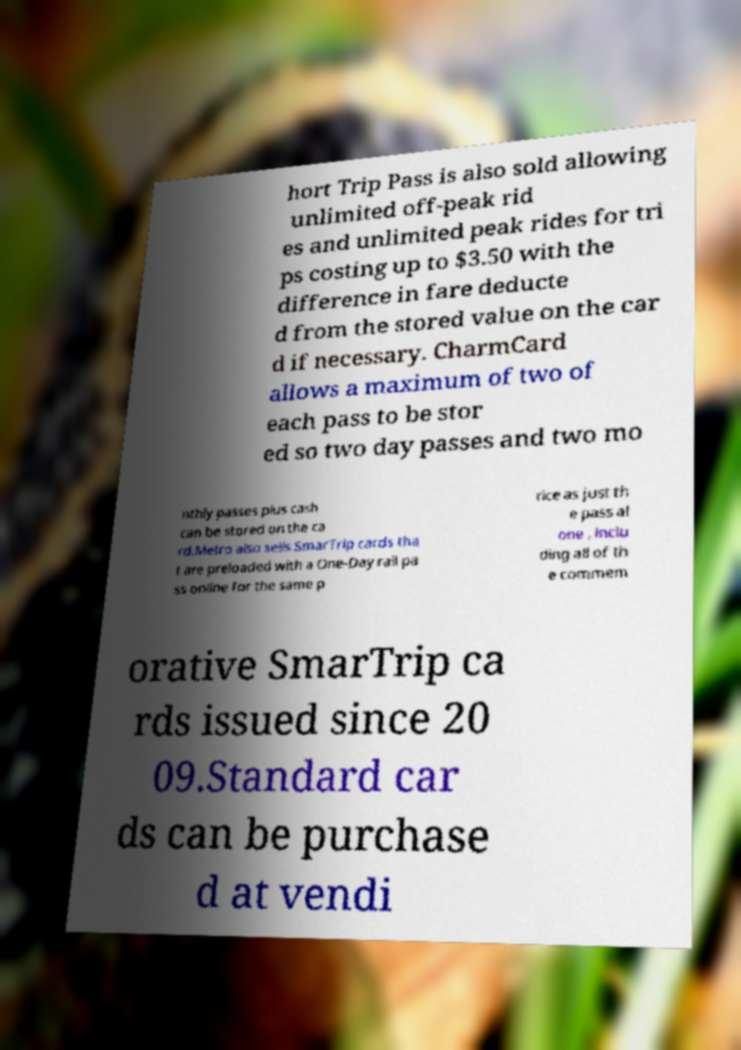Could you assist in decoding the text presented in this image and type it out clearly? hort Trip Pass is also sold allowing unlimited off-peak rid es and unlimited peak rides for tri ps costing up to $3.50 with the difference in fare deducte d from the stored value on the car d if necessary. CharmCard allows a maximum of two of each pass to be stor ed so two day passes and two mo nthly passes plus cash can be stored on the ca rd.Metro also sells SmarTrip cards tha t are preloaded with a One-Day rail pa ss online for the same p rice as just th e pass al one , inclu ding all of th e commem orative SmarTrip ca rds issued since 20 09.Standard car ds can be purchase d at vendi 